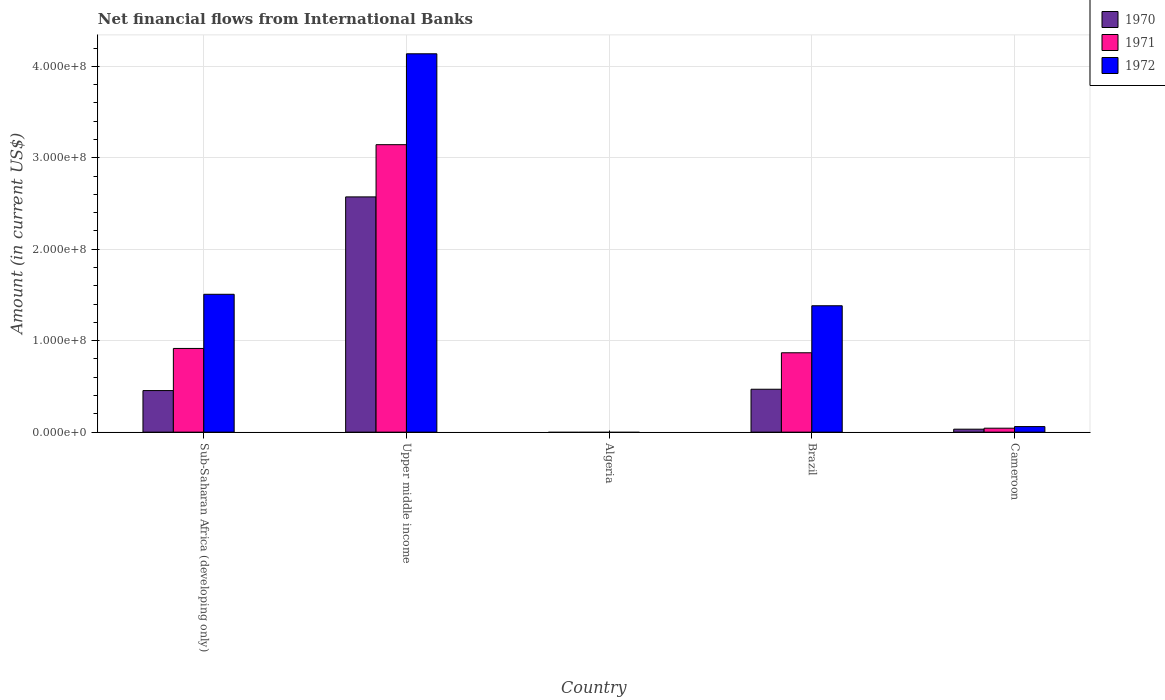How many different coloured bars are there?
Keep it short and to the point. 3. Are the number of bars per tick equal to the number of legend labels?
Your answer should be very brief. No. How many bars are there on the 4th tick from the left?
Your answer should be compact. 3. How many bars are there on the 4th tick from the right?
Make the answer very short. 3. What is the label of the 4th group of bars from the left?
Provide a succinct answer. Brazil. What is the net financial aid flows in 1972 in Sub-Saharan Africa (developing only)?
Ensure brevity in your answer.  1.51e+08. Across all countries, what is the maximum net financial aid flows in 1972?
Offer a terse response. 4.14e+08. Across all countries, what is the minimum net financial aid flows in 1971?
Your response must be concise. 0. In which country was the net financial aid flows in 1971 maximum?
Offer a terse response. Upper middle income. What is the total net financial aid flows in 1972 in the graph?
Offer a terse response. 7.09e+08. What is the difference between the net financial aid flows in 1970 in Brazil and that in Upper middle income?
Offer a very short reply. -2.10e+08. What is the difference between the net financial aid flows in 1972 in Algeria and the net financial aid flows in 1971 in Upper middle income?
Your answer should be very brief. -3.14e+08. What is the average net financial aid flows in 1970 per country?
Your response must be concise. 7.06e+07. What is the difference between the net financial aid flows of/in 1971 and net financial aid flows of/in 1970 in Brazil?
Your answer should be very brief. 3.99e+07. In how many countries, is the net financial aid flows in 1972 greater than 20000000 US$?
Offer a terse response. 3. What is the ratio of the net financial aid flows in 1970 in Brazil to that in Cameroon?
Give a very brief answer. 14.44. Is the net financial aid flows in 1970 in Cameroon less than that in Sub-Saharan Africa (developing only)?
Provide a short and direct response. Yes. Is the difference between the net financial aid flows in 1971 in Brazil and Upper middle income greater than the difference between the net financial aid flows in 1970 in Brazil and Upper middle income?
Your answer should be very brief. No. What is the difference between the highest and the second highest net financial aid flows in 1970?
Your answer should be compact. 2.12e+08. What is the difference between the highest and the lowest net financial aid flows in 1972?
Offer a terse response. 4.14e+08. Is it the case that in every country, the sum of the net financial aid flows in 1971 and net financial aid flows in 1972 is greater than the net financial aid flows in 1970?
Make the answer very short. No. What is the difference between two consecutive major ticks on the Y-axis?
Your response must be concise. 1.00e+08. What is the title of the graph?
Provide a short and direct response. Net financial flows from International Banks. Does "1960" appear as one of the legend labels in the graph?
Offer a terse response. No. What is the label or title of the X-axis?
Offer a very short reply. Country. What is the label or title of the Y-axis?
Your answer should be very brief. Amount (in current US$). What is the Amount (in current US$) of 1970 in Sub-Saharan Africa (developing only)?
Offer a very short reply. 4.55e+07. What is the Amount (in current US$) in 1971 in Sub-Saharan Africa (developing only)?
Your response must be concise. 9.15e+07. What is the Amount (in current US$) of 1972 in Sub-Saharan Africa (developing only)?
Ensure brevity in your answer.  1.51e+08. What is the Amount (in current US$) of 1970 in Upper middle income?
Your answer should be compact. 2.57e+08. What is the Amount (in current US$) of 1971 in Upper middle income?
Offer a terse response. 3.14e+08. What is the Amount (in current US$) of 1972 in Upper middle income?
Offer a very short reply. 4.14e+08. What is the Amount (in current US$) of 1970 in Brazil?
Keep it short and to the point. 4.69e+07. What is the Amount (in current US$) in 1971 in Brazil?
Provide a short and direct response. 8.68e+07. What is the Amount (in current US$) in 1972 in Brazil?
Offer a terse response. 1.38e+08. What is the Amount (in current US$) of 1970 in Cameroon?
Ensure brevity in your answer.  3.25e+06. What is the Amount (in current US$) of 1971 in Cameroon?
Your response must be concise. 4.32e+06. What is the Amount (in current US$) of 1972 in Cameroon?
Offer a very short reply. 6.09e+06. Across all countries, what is the maximum Amount (in current US$) of 1970?
Provide a succinct answer. 2.57e+08. Across all countries, what is the maximum Amount (in current US$) of 1971?
Keep it short and to the point. 3.14e+08. Across all countries, what is the maximum Amount (in current US$) in 1972?
Provide a short and direct response. 4.14e+08. Across all countries, what is the minimum Amount (in current US$) of 1970?
Make the answer very short. 0. Across all countries, what is the minimum Amount (in current US$) in 1971?
Offer a terse response. 0. What is the total Amount (in current US$) of 1970 in the graph?
Provide a succinct answer. 3.53e+08. What is the total Amount (in current US$) in 1971 in the graph?
Make the answer very short. 4.97e+08. What is the total Amount (in current US$) in 1972 in the graph?
Make the answer very short. 7.09e+08. What is the difference between the Amount (in current US$) in 1970 in Sub-Saharan Africa (developing only) and that in Upper middle income?
Your response must be concise. -2.12e+08. What is the difference between the Amount (in current US$) of 1971 in Sub-Saharan Africa (developing only) and that in Upper middle income?
Offer a very short reply. -2.23e+08. What is the difference between the Amount (in current US$) of 1972 in Sub-Saharan Africa (developing only) and that in Upper middle income?
Offer a terse response. -2.63e+08. What is the difference between the Amount (in current US$) of 1970 in Sub-Saharan Africa (developing only) and that in Brazil?
Your response must be concise. -1.45e+06. What is the difference between the Amount (in current US$) of 1971 in Sub-Saharan Africa (developing only) and that in Brazil?
Offer a very short reply. 4.75e+06. What is the difference between the Amount (in current US$) of 1972 in Sub-Saharan Africa (developing only) and that in Brazil?
Provide a succinct answer. 1.25e+07. What is the difference between the Amount (in current US$) in 1970 in Sub-Saharan Africa (developing only) and that in Cameroon?
Provide a succinct answer. 4.22e+07. What is the difference between the Amount (in current US$) of 1971 in Sub-Saharan Africa (developing only) and that in Cameroon?
Ensure brevity in your answer.  8.72e+07. What is the difference between the Amount (in current US$) of 1972 in Sub-Saharan Africa (developing only) and that in Cameroon?
Provide a short and direct response. 1.45e+08. What is the difference between the Amount (in current US$) of 1970 in Upper middle income and that in Brazil?
Offer a very short reply. 2.10e+08. What is the difference between the Amount (in current US$) in 1971 in Upper middle income and that in Brazil?
Keep it short and to the point. 2.28e+08. What is the difference between the Amount (in current US$) in 1972 in Upper middle income and that in Brazil?
Keep it short and to the point. 2.75e+08. What is the difference between the Amount (in current US$) in 1970 in Upper middle income and that in Cameroon?
Make the answer very short. 2.54e+08. What is the difference between the Amount (in current US$) of 1971 in Upper middle income and that in Cameroon?
Your answer should be very brief. 3.10e+08. What is the difference between the Amount (in current US$) in 1972 in Upper middle income and that in Cameroon?
Provide a succinct answer. 4.08e+08. What is the difference between the Amount (in current US$) in 1970 in Brazil and that in Cameroon?
Your answer should be very brief. 4.37e+07. What is the difference between the Amount (in current US$) of 1971 in Brazil and that in Cameroon?
Give a very brief answer. 8.25e+07. What is the difference between the Amount (in current US$) in 1972 in Brazil and that in Cameroon?
Your answer should be compact. 1.32e+08. What is the difference between the Amount (in current US$) of 1970 in Sub-Saharan Africa (developing only) and the Amount (in current US$) of 1971 in Upper middle income?
Give a very brief answer. -2.69e+08. What is the difference between the Amount (in current US$) in 1970 in Sub-Saharan Africa (developing only) and the Amount (in current US$) in 1972 in Upper middle income?
Provide a succinct answer. -3.68e+08. What is the difference between the Amount (in current US$) of 1971 in Sub-Saharan Africa (developing only) and the Amount (in current US$) of 1972 in Upper middle income?
Make the answer very short. -3.22e+08. What is the difference between the Amount (in current US$) in 1970 in Sub-Saharan Africa (developing only) and the Amount (in current US$) in 1971 in Brazil?
Offer a very short reply. -4.13e+07. What is the difference between the Amount (in current US$) of 1970 in Sub-Saharan Africa (developing only) and the Amount (in current US$) of 1972 in Brazil?
Offer a very short reply. -9.27e+07. What is the difference between the Amount (in current US$) in 1971 in Sub-Saharan Africa (developing only) and the Amount (in current US$) in 1972 in Brazil?
Your answer should be compact. -4.67e+07. What is the difference between the Amount (in current US$) of 1970 in Sub-Saharan Africa (developing only) and the Amount (in current US$) of 1971 in Cameroon?
Give a very brief answer. 4.11e+07. What is the difference between the Amount (in current US$) in 1970 in Sub-Saharan Africa (developing only) and the Amount (in current US$) in 1972 in Cameroon?
Provide a succinct answer. 3.94e+07. What is the difference between the Amount (in current US$) of 1971 in Sub-Saharan Africa (developing only) and the Amount (in current US$) of 1972 in Cameroon?
Offer a very short reply. 8.54e+07. What is the difference between the Amount (in current US$) of 1970 in Upper middle income and the Amount (in current US$) of 1971 in Brazil?
Your response must be concise. 1.70e+08. What is the difference between the Amount (in current US$) in 1970 in Upper middle income and the Amount (in current US$) in 1972 in Brazil?
Your answer should be compact. 1.19e+08. What is the difference between the Amount (in current US$) of 1971 in Upper middle income and the Amount (in current US$) of 1972 in Brazil?
Make the answer very short. 1.76e+08. What is the difference between the Amount (in current US$) of 1970 in Upper middle income and the Amount (in current US$) of 1971 in Cameroon?
Ensure brevity in your answer.  2.53e+08. What is the difference between the Amount (in current US$) in 1970 in Upper middle income and the Amount (in current US$) in 1972 in Cameroon?
Provide a succinct answer. 2.51e+08. What is the difference between the Amount (in current US$) in 1971 in Upper middle income and the Amount (in current US$) in 1972 in Cameroon?
Your answer should be compact. 3.08e+08. What is the difference between the Amount (in current US$) of 1970 in Brazil and the Amount (in current US$) of 1971 in Cameroon?
Provide a succinct answer. 4.26e+07. What is the difference between the Amount (in current US$) of 1970 in Brazil and the Amount (in current US$) of 1972 in Cameroon?
Your answer should be very brief. 4.08e+07. What is the difference between the Amount (in current US$) in 1971 in Brazil and the Amount (in current US$) in 1972 in Cameroon?
Give a very brief answer. 8.07e+07. What is the average Amount (in current US$) of 1970 per country?
Give a very brief answer. 7.06e+07. What is the average Amount (in current US$) in 1971 per country?
Ensure brevity in your answer.  9.94e+07. What is the average Amount (in current US$) of 1972 per country?
Your answer should be very brief. 1.42e+08. What is the difference between the Amount (in current US$) of 1970 and Amount (in current US$) of 1971 in Sub-Saharan Africa (developing only)?
Ensure brevity in your answer.  -4.61e+07. What is the difference between the Amount (in current US$) of 1970 and Amount (in current US$) of 1972 in Sub-Saharan Africa (developing only)?
Your response must be concise. -1.05e+08. What is the difference between the Amount (in current US$) of 1971 and Amount (in current US$) of 1972 in Sub-Saharan Africa (developing only)?
Your answer should be very brief. -5.92e+07. What is the difference between the Amount (in current US$) in 1970 and Amount (in current US$) in 1971 in Upper middle income?
Ensure brevity in your answer.  -5.71e+07. What is the difference between the Amount (in current US$) of 1970 and Amount (in current US$) of 1972 in Upper middle income?
Your response must be concise. -1.56e+08. What is the difference between the Amount (in current US$) in 1971 and Amount (in current US$) in 1972 in Upper middle income?
Keep it short and to the point. -9.94e+07. What is the difference between the Amount (in current US$) in 1970 and Amount (in current US$) in 1971 in Brazil?
Give a very brief answer. -3.99e+07. What is the difference between the Amount (in current US$) of 1970 and Amount (in current US$) of 1972 in Brazil?
Offer a very short reply. -9.13e+07. What is the difference between the Amount (in current US$) of 1971 and Amount (in current US$) of 1972 in Brazil?
Make the answer very short. -5.14e+07. What is the difference between the Amount (in current US$) in 1970 and Amount (in current US$) in 1971 in Cameroon?
Provide a short and direct response. -1.07e+06. What is the difference between the Amount (in current US$) of 1970 and Amount (in current US$) of 1972 in Cameroon?
Ensure brevity in your answer.  -2.84e+06. What is the difference between the Amount (in current US$) in 1971 and Amount (in current US$) in 1972 in Cameroon?
Your response must be concise. -1.77e+06. What is the ratio of the Amount (in current US$) of 1970 in Sub-Saharan Africa (developing only) to that in Upper middle income?
Make the answer very short. 0.18. What is the ratio of the Amount (in current US$) in 1971 in Sub-Saharan Africa (developing only) to that in Upper middle income?
Keep it short and to the point. 0.29. What is the ratio of the Amount (in current US$) in 1972 in Sub-Saharan Africa (developing only) to that in Upper middle income?
Your answer should be very brief. 0.36. What is the ratio of the Amount (in current US$) of 1970 in Sub-Saharan Africa (developing only) to that in Brazil?
Your response must be concise. 0.97. What is the ratio of the Amount (in current US$) of 1971 in Sub-Saharan Africa (developing only) to that in Brazil?
Your answer should be very brief. 1.05. What is the ratio of the Amount (in current US$) of 1972 in Sub-Saharan Africa (developing only) to that in Brazil?
Your response must be concise. 1.09. What is the ratio of the Amount (in current US$) of 1970 in Sub-Saharan Africa (developing only) to that in Cameroon?
Give a very brief answer. 13.99. What is the ratio of the Amount (in current US$) of 1971 in Sub-Saharan Africa (developing only) to that in Cameroon?
Your answer should be compact. 21.2. What is the ratio of the Amount (in current US$) of 1972 in Sub-Saharan Africa (developing only) to that in Cameroon?
Your response must be concise. 24.76. What is the ratio of the Amount (in current US$) of 1970 in Upper middle income to that in Brazil?
Provide a succinct answer. 5.48. What is the ratio of the Amount (in current US$) in 1971 in Upper middle income to that in Brazil?
Provide a succinct answer. 3.62. What is the ratio of the Amount (in current US$) in 1972 in Upper middle income to that in Brazil?
Ensure brevity in your answer.  2.99. What is the ratio of the Amount (in current US$) in 1970 in Upper middle income to that in Cameroon?
Provide a short and direct response. 79.15. What is the ratio of the Amount (in current US$) of 1971 in Upper middle income to that in Cameroon?
Your response must be concise. 72.81. What is the ratio of the Amount (in current US$) of 1972 in Upper middle income to that in Cameroon?
Your answer should be compact. 67.96. What is the ratio of the Amount (in current US$) of 1970 in Brazil to that in Cameroon?
Ensure brevity in your answer.  14.44. What is the ratio of the Amount (in current US$) of 1971 in Brazil to that in Cameroon?
Your answer should be compact. 20.1. What is the ratio of the Amount (in current US$) in 1972 in Brazil to that in Cameroon?
Make the answer very short. 22.7. What is the difference between the highest and the second highest Amount (in current US$) of 1970?
Provide a short and direct response. 2.10e+08. What is the difference between the highest and the second highest Amount (in current US$) in 1971?
Provide a succinct answer. 2.23e+08. What is the difference between the highest and the second highest Amount (in current US$) of 1972?
Offer a terse response. 2.63e+08. What is the difference between the highest and the lowest Amount (in current US$) of 1970?
Ensure brevity in your answer.  2.57e+08. What is the difference between the highest and the lowest Amount (in current US$) of 1971?
Offer a terse response. 3.14e+08. What is the difference between the highest and the lowest Amount (in current US$) of 1972?
Keep it short and to the point. 4.14e+08. 